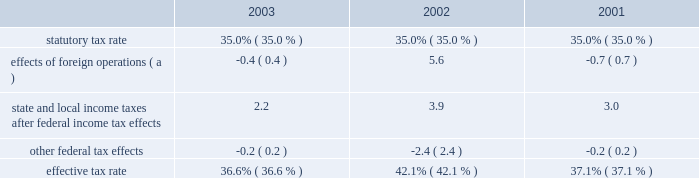Expenditures and acquisitions of leased properties are funded by the original contributor of the assets , but no change in ownership interest may result from these contributions .
An excess of ashland funded improvements over marathon funded improvements results in a net gain and an excess of marathon funded improvements over ashland funded improvements results in a net loss .
Cost of revenues increased by $ 8.718 billion in 2003 from 2002 and $ 367 million in 2002 from 2001 .
The increases in the oerb segment were primarily a result of higher natural gas and liquid hydrocarbon costs .
The increases in the rm&t segment primarily reflected higher acquisition costs for crude oil , refined products , refinery charge and blend feedstocks and increased manufacturing expenses .
Selling , general and administrative expenses increased by $ 107 million in 2003 from 2002 and $ 125 million in 2002 from 2001 .
The increase in 2003 was primarily a result of increased employee benefits ( caused by increased pension expense resulting from changes in actuarial assumptions and a decrease in realized returns on plan assets ) and other employee related costs .
Also , marathon changed assumptions in the health care cost trend rate from 7.5% ( 7.5 % ) to 10% ( 10 % ) , resulting in higher retiree health care costs .
Additionally , during 2003 , marathon recorded a charge of $ 24 million related to organizational and business process changes .
The increase in 2002 primarily reflected increased employee related costs .
Inventory market valuation reserve is established to reduce the cost basis of inventories to current market value .
The 2002 results of operations include credits to income from operations of $ 71 million , reversing the imv reserve at december 31 , 2001 .
For additional information on this adjustment , see 201cmanagement 2019s discussion and analysis of critical accounting estimates 2013 net realizable value of inventories 201d on page 31 .
Net interest and other financial costs decreased by $ 82 million in 2003 from 2002 , following an increase of $ 96 million in 2002 from 2001 .
The decrease in 2003 is primarily due to an increase in capitalized interest related to increased long-term construction projects , the favorable effect of interest rate swaps , the favorable effect of interest on tax deficiencies and increased interest income on investments .
The increase in 2002 was primarily due to higher average debt levels resulting from acquisitions and the separation .
Additionally , included in net interest and other financing costs are foreign currency gains of $ 13 million and $ 8 million for 2003 and 2002 and losses of $ 5 million for 2001 .
Loss from early extinguishment of debt in 2002 was attributable to the retirement of $ 337 million aggregate principal amount of debt , resulting in a loss of $ 53 million .
As a result of the adoption of statement of financial accounting standards no .
145 201crescission of fasb statements no .
4 , 44 , and 64 , amendment of fasb statement no .
13 , and technical corrections 201d ( 201csfas no .
145 201d ) , the loss from early extinguishment of debt that was previously reported as an extraordinary item ( net of taxes of $ 20 million ) has been reclassified into income before income taxes .
The adoption of sfas no .
145 had no impact on net income for 2002 .
Minority interest in income of map , which represents ashland 2019s 38 percent ownership interest , increased by $ 129 million in 2003 from 2002 , following a decrease of $ 531 million in 2002 from 2001 .
Map income was higher in 2003 compared to 2002 as discussed below in the rm&t segment .
Map income was significantly lower in 2002 compared to 2001 as discussed below in the rm&t segment .
Provision for income taxes increased by $ 215 million in 2003 from 2002 , following a decrease of $ 458 million in 2002 from 2001 , primarily due to $ 720 million increase and $ 1.356 billion decrease in income before income taxes .
The effective tax rate for 2003 was 36.6% ( 36.6 % ) compared to 42.1% ( 42.1 % ) and 37.1% ( 37.1 % ) for 2002 and 2001 .
The higher rate in 2002 was due to the united kingdom enactment of a supplementary 10 percent tax on profits from the north sea oil and gas production , retroactively effective to april 17 , 2002 .
In 2002 , marathon recognized a one-time noncash deferred tax adjustment of $ 61 million as a result of the rate increase .
The following is an analysis of the effective tax rate for the periods presented: .
( a ) the deferred tax effect related to the enactment of a supplemental tax in the u.k .
Increased the effective tax rate 7.0 percent in 2002. .
What were average state and local income taxes after federal income tax effects for the three year period , in millions? 
Computations: table_average(state and local income taxes after federal income tax effects, none)
Answer: 3.03333. 